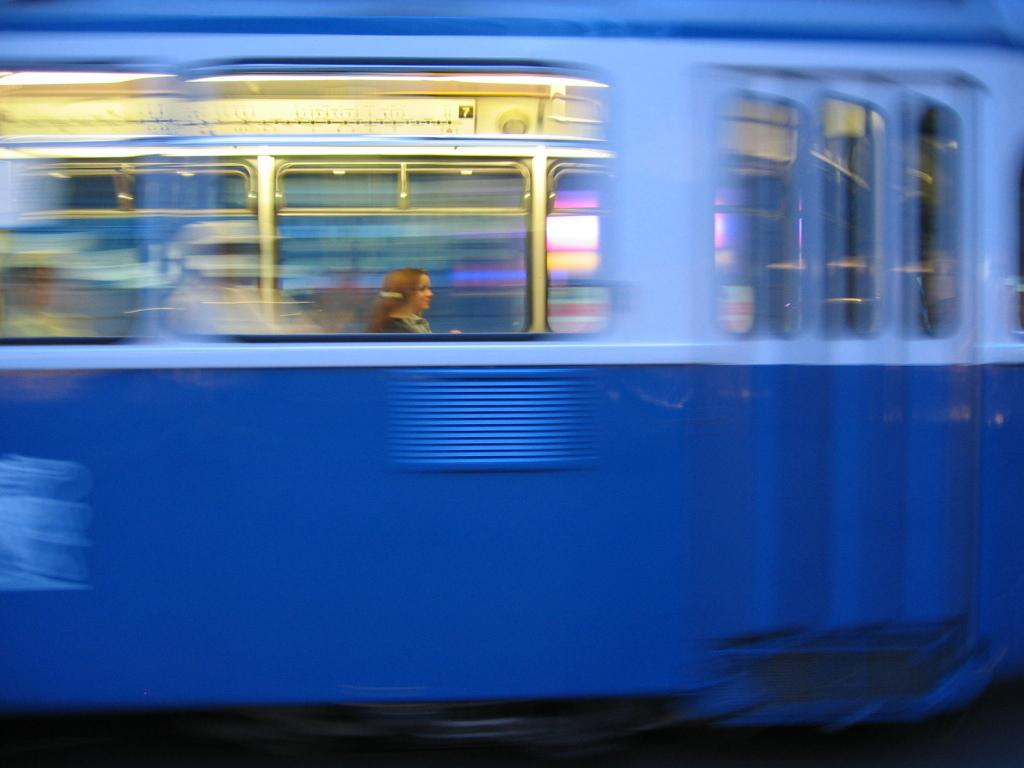What is the main subject of the image? The main subject of the image is a vehicle. Can you describe the color of the vehicle? The vehicle is blue. What feature does the vehicle have that allows for visibility? The vehicle has windows. Is there anyone inside the vehicle? Yes, there is a person inside the vehicle. What type of smell can be detected coming from the vehicle in the image? There is no information about smells in the image, so it cannot be determined from the picture. 